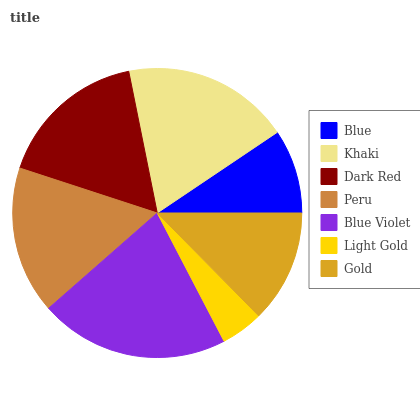Is Light Gold the minimum?
Answer yes or no. Yes. Is Blue Violet the maximum?
Answer yes or no. Yes. Is Khaki the minimum?
Answer yes or no. No. Is Khaki the maximum?
Answer yes or no. No. Is Khaki greater than Blue?
Answer yes or no. Yes. Is Blue less than Khaki?
Answer yes or no. Yes. Is Blue greater than Khaki?
Answer yes or no. No. Is Khaki less than Blue?
Answer yes or no. No. Is Peru the high median?
Answer yes or no. Yes. Is Peru the low median?
Answer yes or no. Yes. Is Blue the high median?
Answer yes or no. No. Is Blue the low median?
Answer yes or no. No. 